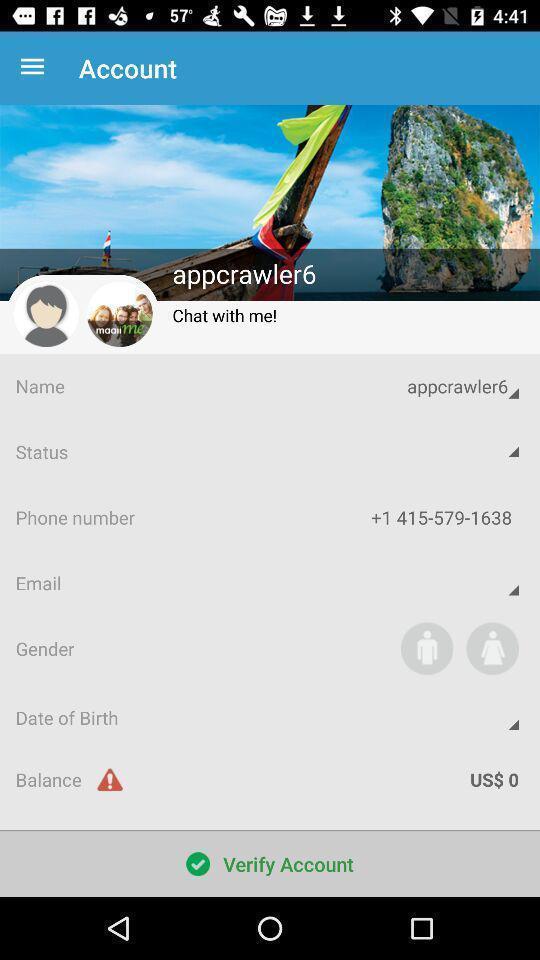Provide a detailed account of this screenshot. Page showing the profile details. 